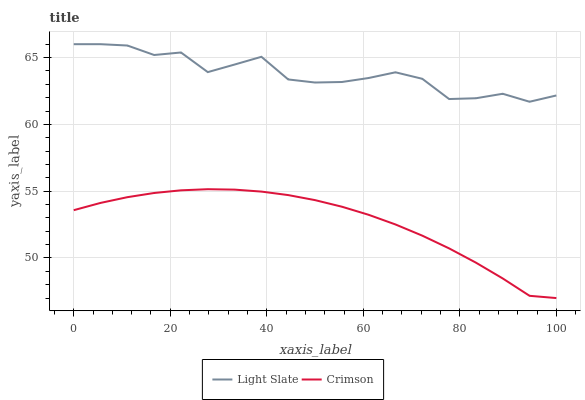Does Crimson have the minimum area under the curve?
Answer yes or no. Yes. Does Light Slate have the maximum area under the curve?
Answer yes or no. Yes. Does Crimson have the maximum area under the curve?
Answer yes or no. No. Is Crimson the smoothest?
Answer yes or no. Yes. Is Light Slate the roughest?
Answer yes or no. Yes. Is Crimson the roughest?
Answer yes or no. No. Does Crimson have the lowest value?
Answer yes or no. Yes. Does Light Slate have the highest value?
Answer yes or no. Yes. Does Crimson have the highest value?
Answer yes or no. No. Is Crimson less than Light Slate?
Answer yes or no. Yes. Is Light Slate greater than Crimson?
Answer yes or no. Yes. Does Crimson intersect Light Slate?
Answer yes or no. No. 